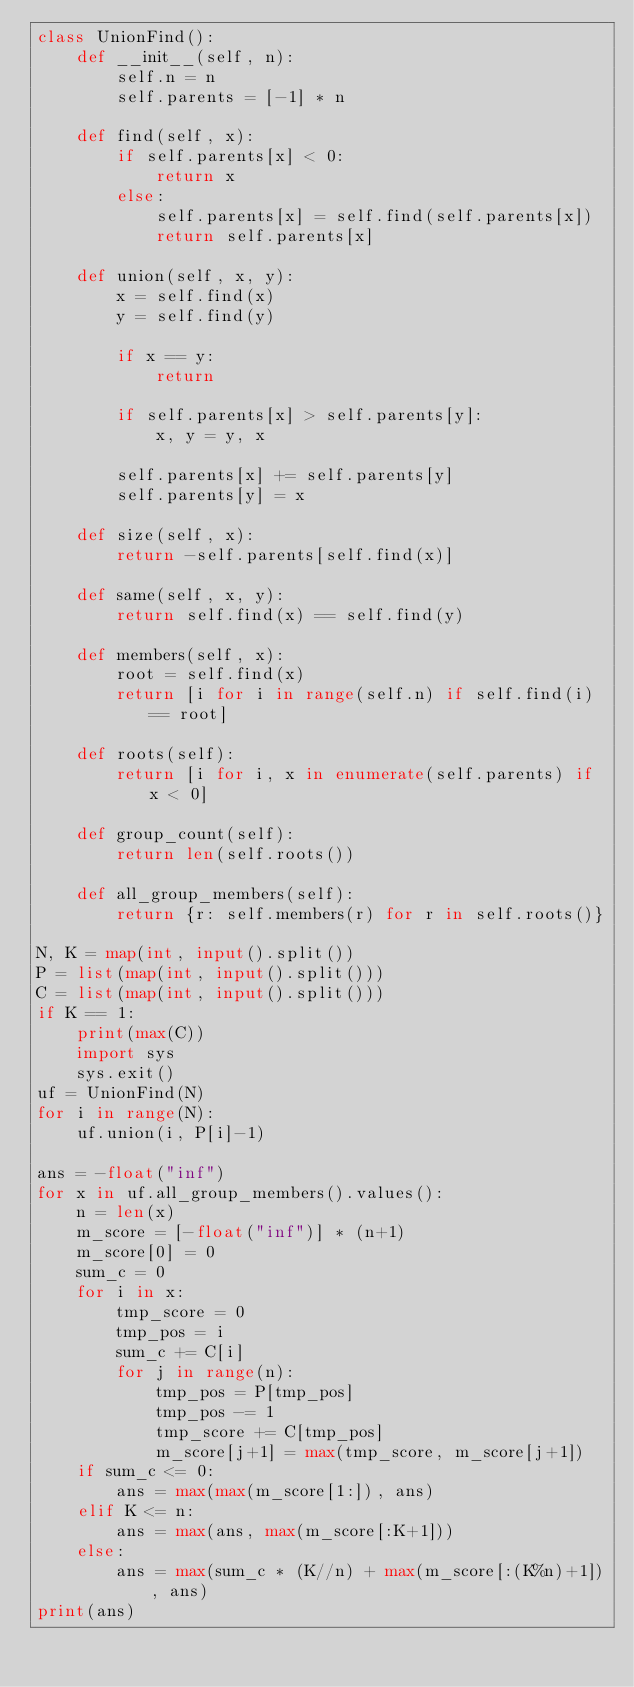Convert code to text. <code><loc_0><loc_0><loc_500><loc_500><_Python_>class UnionFind():
    def __init__(self, n):
        self.n = n
        self.parents = [-1] * n

    def find(self, x):
        if self.parents[x] < 0:
            return x
        else:
            self.parents[x] = self.find(self.parents[x])
            return self.parents[x]

    def union(self, x, y):
        x = self.find(x)
        y = self.find(y)

        if x == y:
            return

        if self.parents[x] > self.parents[y]:
            x, y = y, x

        self.parents[x] += self.parents[y]
        self.parents[y] = x

    def size(self, x):
        return -self.parents[self.find(x)]

    def same(self, x, y):
        return self.find(x) == self.find(y)

    def members(self, x):
        root = self.find(x)
        return [i for i in range(self.n) if self.find(i) == root]

    def roots(self):
        return [i for i, x in enumerate(self.parents) if x < 0]

    def group_count(self):
        return len(self.roots())

    def all_group_members(self):
        return {r: self.members(r) for r in self.roots()}

N, K = map(int, input().split())
P = list(map(int, input().split()))
C = list(map(int, input().split()))
if K == 1:
    print(max(C))
    import sys
    sys.exit()
uf = UnionFind(N)
for i in range(N):
    uf.union(i, P[i]-1)

ans = -float("inf")
for x in uf.all_group_members().values():
    n = len(x)
    m_score = [-float("inf")] * (n+1)
    m_score[0] = 0
    sum_c = 0
    for i in x:
        tmp_score = 0
        tmp_pos = i
        sum_c += C[i]
        for j in range(n):
            tmp_pos = P[tmp_pos]
            tmp_pos -= 1
            tmp_score += C[tmp_pos]
            m_score[j+1] = max(tmp_score, m_score[j+1])
    if sum_c <= 0:
        ans = max(max(m_score[1:]), ans)
    elif K <= n:
        ans = max(ans, max(m_score[:K+1]))
    else:
        ans = max(sum_c * (K//n) + max(m_score[:(K%n)+1]), ans)
print(ans)</code> 